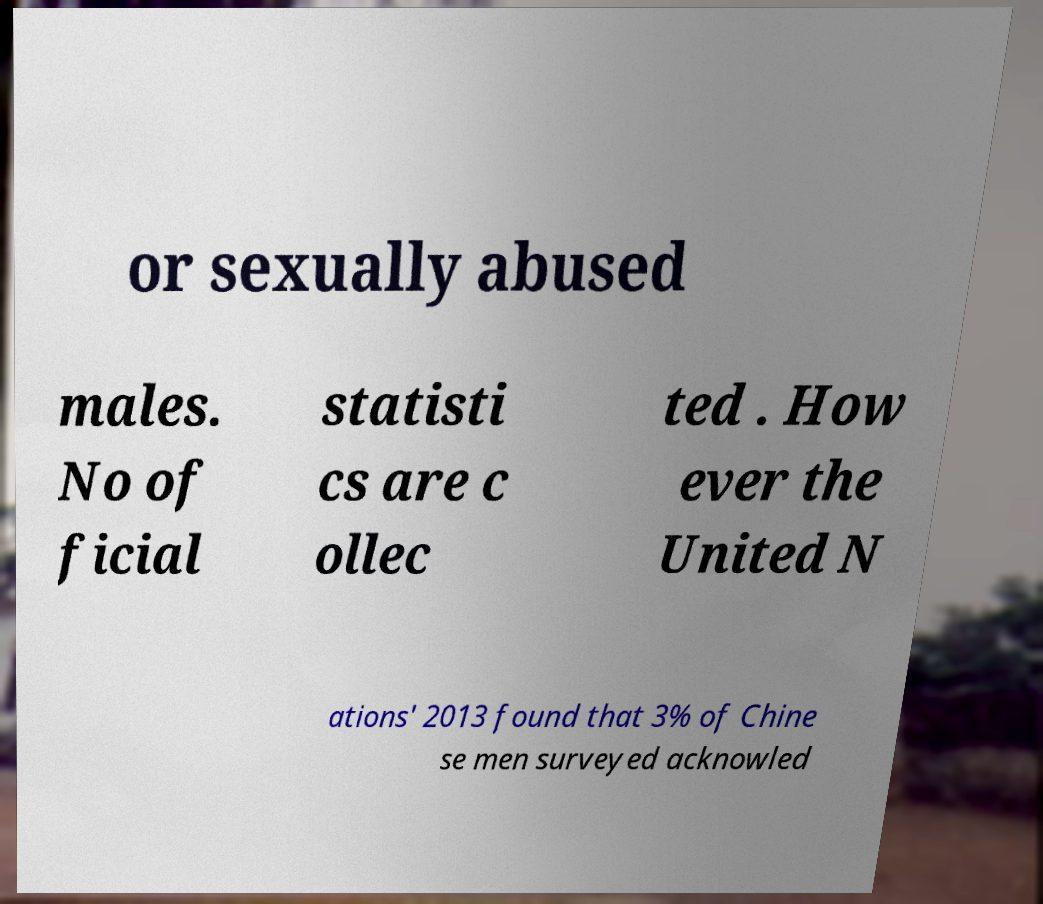Please read and relay the text visible in this image. What does it say? or sexually abused males. No of ficial statisti cs are c ollec ted . How ever the United N ations' 2013 found that 3% of Chine se men surveyed acknowled 